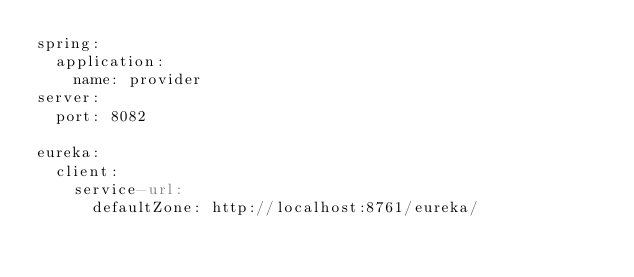Convert code to text. <code><loc_0><loc_0><loc_500><loc_500><_YAML_>spring:
  application:
    name: provider
server:
  port: 8082

eureka:
  client:
    service-url:
      defaultZone: http://localhost:8761/eureka/
</code> 